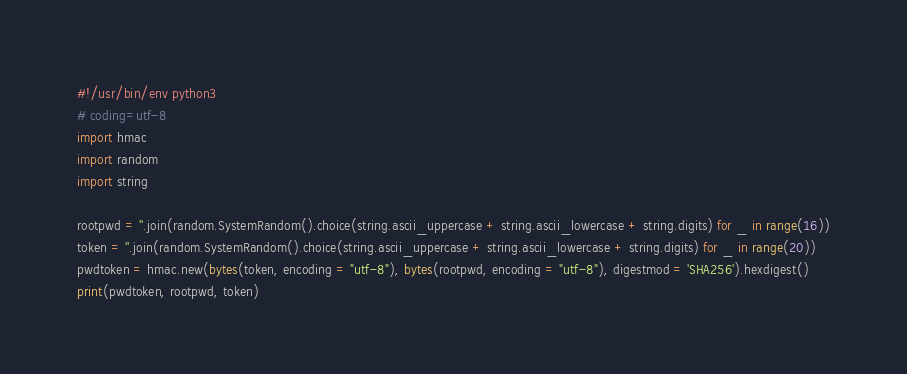<code> <loc_0><loc_0><loc_500><loc_500><_Python_>#!/usr/bin/env python3
# coding=utf-8
import hmac
import random
import string

rootpwd = ''.join(random.SystemRandom().choice(string.ascii_uppercase + string.ascii_lowercase + string.digits) for _ in range(16))
token = ''.join(random.SystemRandom().choice(string.ascii_uppercase + string.ascii_lowercase + string.digits) for _ in range(20))
pwdtoken = hmac.new(bytes(token, encoding = "utf-8"), bytes(rootpwd, encoding = "utf-8"), digestmod = 'SHA256').hexdigest()
print(pwdtoken, rootpwd, token)
</code> 